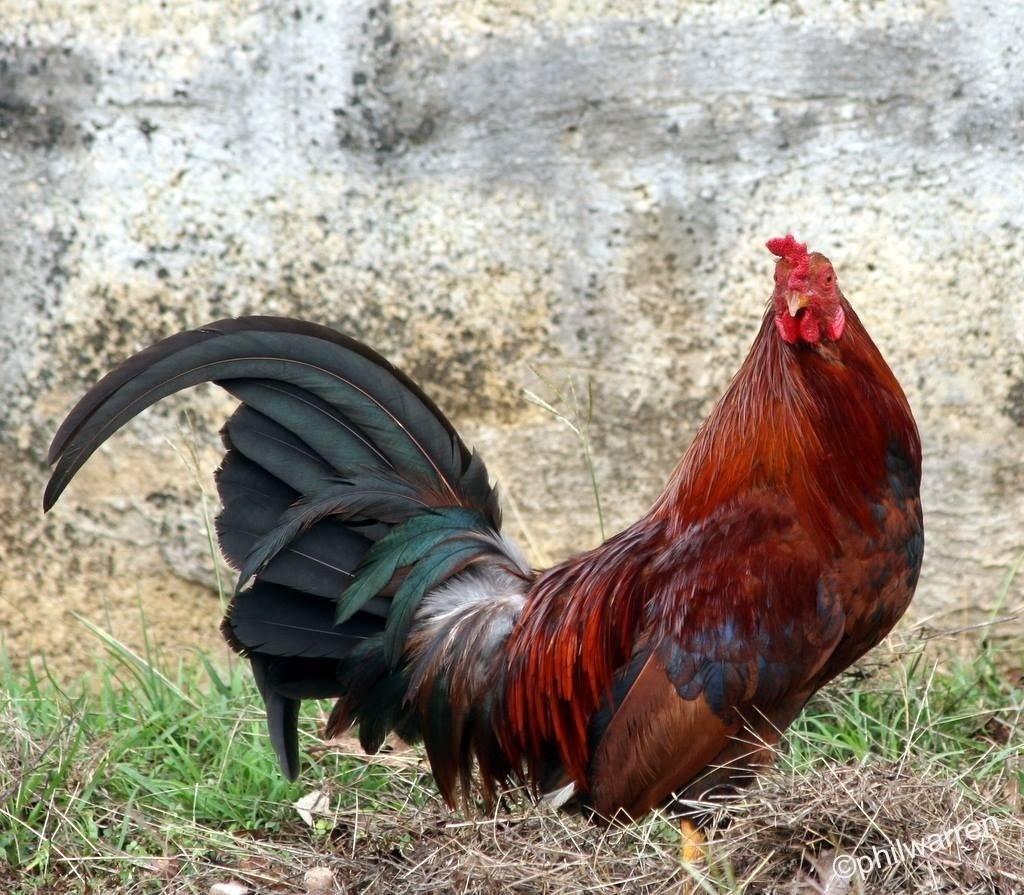In one or two sentences, can you explain what this image depicts? In this image we can see a hen on the ground. In the background, we can see the grass and the wall. In the bottom right corner of the image we can see some text. 